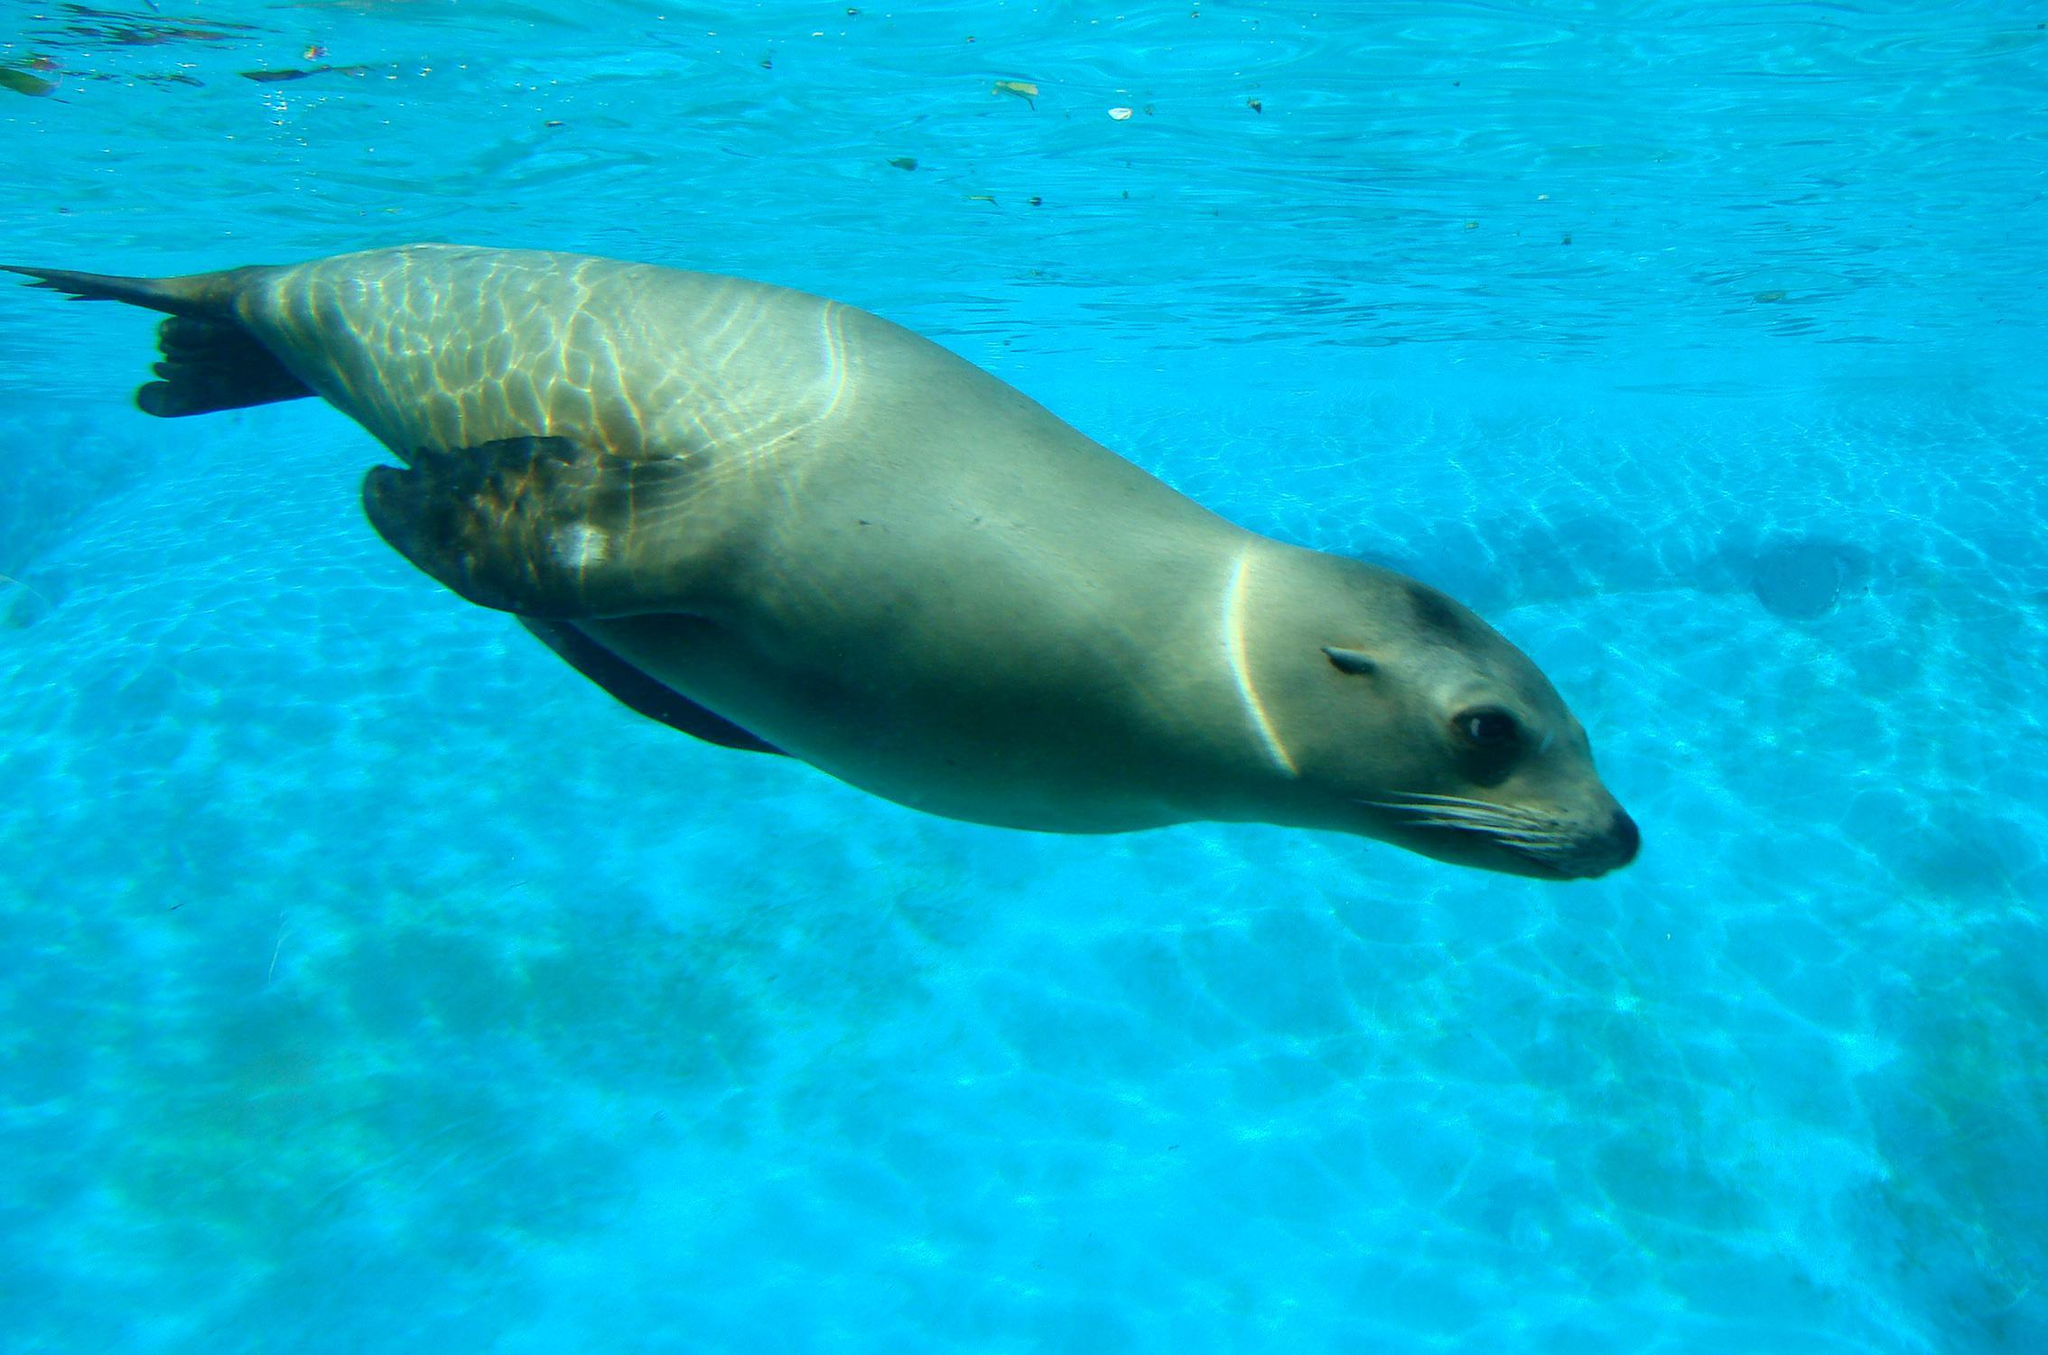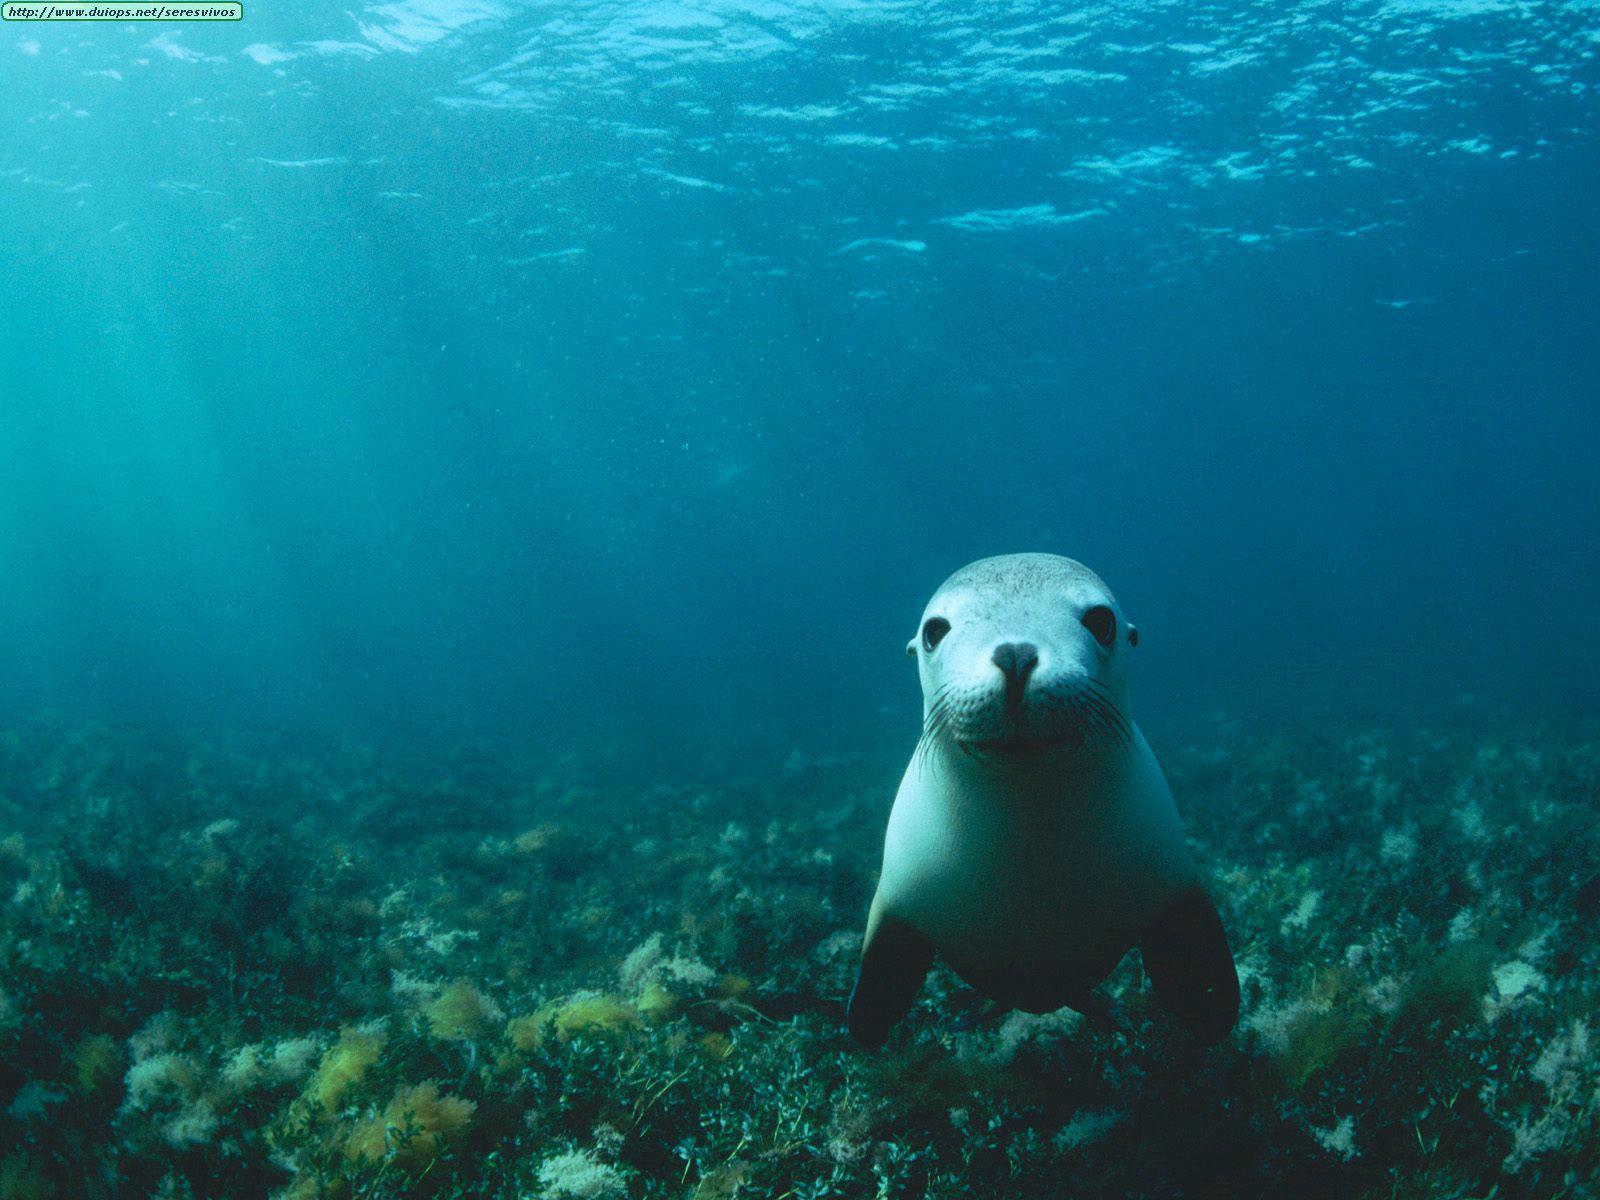The first image is the image on the left, the second image is the image on the right. Considering the images on both sides, is "A total of two seals are shown, all of them swimming underwater, and one seal is swimming forward and eyeing the camera." valid? Answer yes or no. Yes. The first image is the image on the left, the second image is the image on the right. For the images shown, is this caption "There are at least two seals in the right image swimming underwater." true? Answer yes or no. No. 